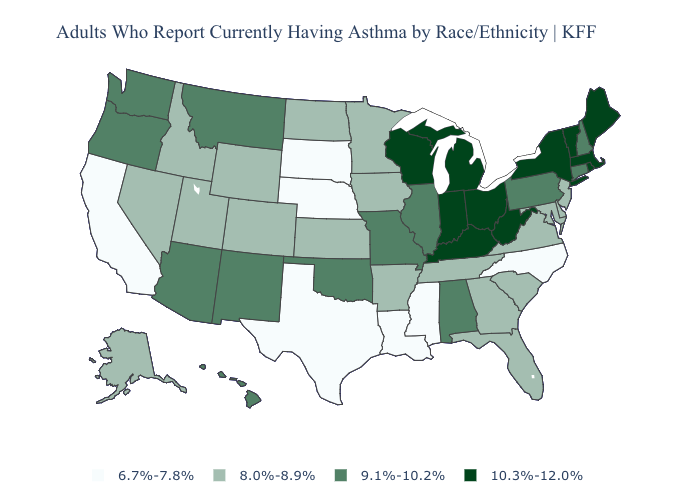Does the first symbol in the legend represent the smallest category?
Write a very short answer. Yes. What is the value of Utah?
Give a very brief answer. 8.0%-8.9%. What is the lowest value in states that border Vermont?
Concise answer only. 9.1%-10.2%. What is the highest value in the West ?
Keep it brief. 9.1%-10.2%. Does Oklahoma have the highest value in the South?
Quick response, please. No. Which states have the lowest value in the USA?
Be succinct. California, Louisiana, Mississippi, Nebraska, North Carolina, South Dakota, Texas. Does Ohio have the highest value in the USA?
Short answer required. Yes. Which states have the highest value in the USA?
Give a very brief answer. Indiana, Kentucky, Maine, Massachusetts, Michigan, New York, Ohio, Rhode Island, Vermont, West Virginia, Wisconsin. What is the highest value in the USA?
Be succinct. 10.3%-12.0%. How many symbols are there in the legend?
Write a very short answer. 4. Does the first symbol in the legend represent the smallest category?
Keep it brief. Yes. Name the states that have a value in the range 8.0%-8.9%?
Keep it brief. Alaska, Arkansas, Colorado, Delaware, Florida, Georgia, Idaho, Iowa, Kansas, Maryland, Minnesota, Nevada, New Jersey, North Dakota, South Carolina, Tennessee, Utah, Virginia, Wyoming. Name the states that have a value in the range 9.1%-10.2%?
Answer briefly. Alabama, Arizona, Connecticut, Hawaii, Illinois, Missouri, Montana, New Hampshire, New Mexico, Oklahoma, Oregon, Pennsylvania, Washington. Name the states that have a value in the range 10.3%-12.0%?
Quick response, please. Indiana, Kentucky, Maine, Massachusetts, Michigan, New York, Ohio, Rhode Island, Vermont, West Virginia, Wisconsin. What is the highest value in the West ?
Be succinct. 9.1%-10.2%. 